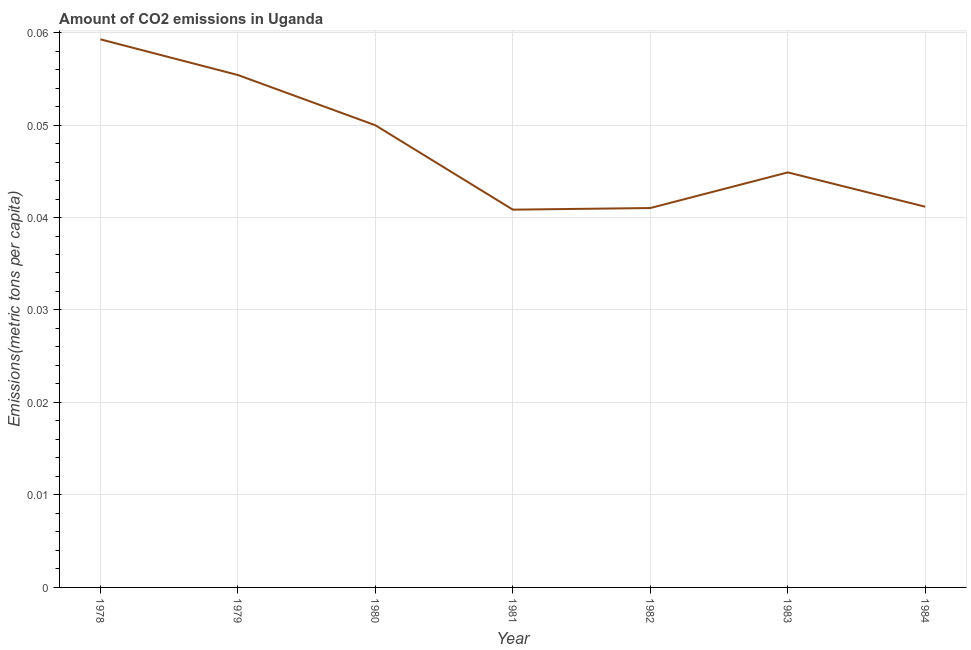What is the amount of co2 emissions in 1978?
Make the answer very short. 0.06. Across all years, what is the maximum amount of co2 emissions?
Provide a short and direct response. 0.06. Across all years, what is the minimum amount of co2 emissions?
Give a very brief answer. 0.04. In which year was the amount of co2 emissions maximum?
Make the answer very short. 1978. In which year was the amount of co2 emissions minimum?
Provide a short and direct response. 1981. What is the sum of the amount of co2 emissions?
Offer a very short reply. 0.33. What is the difference between the amount of co2 emissions in 1982 and 1984?
Give a very brief answer. -0. What is the average amount of co2 emissions per year?
Provide a short and direct response. 0.05. What is the median amount of co2 emissions?
Your response must be concise. 0.04. In how many years, is the amount of co2 emissions greater than 0.002 metric tons per capita?
Your response must be concise. 7. What is the ratio of the amount of co2 emissions in 1982 to that in 1983?
Keep it short and to the point. 0.91. Is the amount of co2 emissions in 1983 less than that in 1984?
Your response must be concise. No. What is the difference between the highest and the second highest amount of co2 emissions?
Your response must be concise. 0. What is the difference between the highest and the lowest amount of co2 emissions?
Keep it short and to the point. 0.02. In how many years, is the amount of co2 emissions greater than the average amount of co2 emissions taken over all years?
Provide a succinct answer. 3. Does the amount of co2 emissions monotonically increase over the years?
Provide a succinct answer. No. What is the difference between two consecutive major ticks on the Y-axis?
Make the answer very short. 0.01. What is the title of the graph?
Make the answer very short. Amount of CO2 emissions in Uganda. What is the label or title of the Y-axis?
Your answer should be very brief. Emissions(metric tons per capita). What is the Emissions(metric tons per capita) of 1978?
Your response must be concise. 0.06. What is the Emissions(metric tons per capita) of 1979?
Make the answer very short. 0.06. What is the Emissions(metric tons per capita) in 1980?
Provide a succinct answer. 0.05. What is the Emissions(metric tons per capita) of 1981?
Make the answer very short. 0.04. What is the Emissions(metric tons per capita) of 1982?
Your response must be concise. 0.04. What is the Emissions(metric tons per capita) of 1983?
Your answer should be very brief. 0.04. What is the Emissions(metric tons per capita) in 1984?
Offer a very short reply. 0.04. What is the difference between the Emissions(metric tons per capita) in 1978 and 1979?
Your response must be concise. 0. What is the difference between the Emissions(metric tons per capita) in 1978 and 1980?
Provide a short and direct response. 0.01. What is the difference between the Emissions(metric tons per capita) in 1978 and 1981?
Keep it short and to the point. 0.02. What is the difference between the Emissions(metric tons per capita) in 1978 and 1982?
Make the answer very short. 0.02. What is the difference between the Emissions(metric tons per capita) in 1978 and 1983?
Your answer should be compact. 0.01. What is the difference between the Emissions(metric tons per capita) in 1978 and 1984?
Your answer should be very brief. 0.02. What is the difference between the Emissions(metric tons per capita) in 1979 and 1980?
Your answer should be very brief. 0.01. What is the difference between the Emissions(metric tons per capita) in 1979 and 1981?
Provide a short and direct response. 0.01. What is the difference between the Emissions(metric tons per capita) in 1979 and 1982?
Your response must be concise. 0.01. What is the difference between the Emissions(metric tons per capita) in 1979 and 1983?
Provide a succinct answer. 0.01. What is the difference between the Emissions(metric tons per capita) in 1979 and 1984?
Offer a terse response. 0.01. What is the difference between the Emissions(metric tons per capita) in 1980 and 1981?
Keep it short and to the point. 0.01. What is the difference between the Emissions(metric tons per capita) in 1980 and 1982?
Keep it short and to the point. 0.01. What is the difference between the Emissions(metric tons per capita) in 1980 and 1983?
Provide a succinct answer. 0.01. What is the difference between the Emissions(metric tons per capita) in 1980 and 1984?
Offer a terse response. 0.01. What is the difference between the Emissions(metric tons per capita) in 1981 and 1982?
Your response must be concise. -0. What is the difference between the Emissions(metric tons per capita) in 1981 and 1983?
Make the answer very short. -0. What is the difference between the Emissions(metric tons per capita) in 1981 and 1984?
Your answer should be compact. -0. What is the difference between the Emissions(metric tons per capita) in 1982 and 1983?
Provide a succinct answer. -0. What is the difference between the Emissions(metric tons per capita) in 1982 and 1984?
Provide a succinct answer. -0. What is the difference between the Emissions(metric tons per capita) in 1983 and 1984?
Give a very brief answer. 0. What is the ratio of the Emissions(metric tons per capita) in 1978 to that in 1979?
Offer a very short reply. 1.07. What is the ratio of the Emissions(metric tons per capita) in 1978 to that in 1980?
Provide a short and direct response. 1.19. What is the ratio of the Emissions(metric tons per capita) in 1978 to that in 1981?
Keep it short and to the point. 1.45. What is the ratio of the Emissions(metric tons per capita) in 1978 to that in 1982?
Your answer should be very brief. 1.45. What is the ratio of the Emissions(metric tons per capita) in 1978 to that in 1983?
Keep it short and to the point. 1.32. What is the ratio of the Emissions(metric tons per capita) in 1978 to that in 1984?
Your response must be concise. 1.44. What is the ratio of the Emissions(metric tons per capita) in 1979 to that in 1980?
Offer a terse response. 1.11. What is the ratio of the Emissions(metric tons per capita) in 1979 to that in 1981?
Keep it short and to the point. 1.36. What is the ratio of the Emissions(metric tons per capita) in 1979 to that in 1982?
Give a very brief answer. 1.35. What is the ratio of the Emissions(metric tons per capita) in 1979 to that in 1983?
Offer a terse response. 1.24. What is the ratio of the Emissions(metric tons per capita) in 1979 to that in 1984?
Keep it short and to the point. 1.35. What is the ratio of the Emissions(metric tons per capita) in 1980 to that in 1981?
Provide a succinct answer. 1.22. What is the ratio of the Emissions(metric tons per capita) in 1980 to that in 1982?
Keep it short and to the point. 1.22. What is the ratio of the Emissions(metric tons per capita) in 1980 to that in 1983?
Offer a very short reply. 1.11. What is the ratio of the Emissions(metric tons per capita) in 1980 to that in 1984?
Offer a very short reply. 1.21. What is the ratio of the Emissions(metric tons per capita) in 1981 to that in 1983?
Keep it short and to the point. 0.91. What is the ratio of the Emissions(metric tons per capita) in 1982 to that in 1983?
Provide a succinct answer. 0.91. What is the ratio of the Emissions(metric tons per capita) in 1983 to that in 1984?
Give a very brief answer. 1.09. 